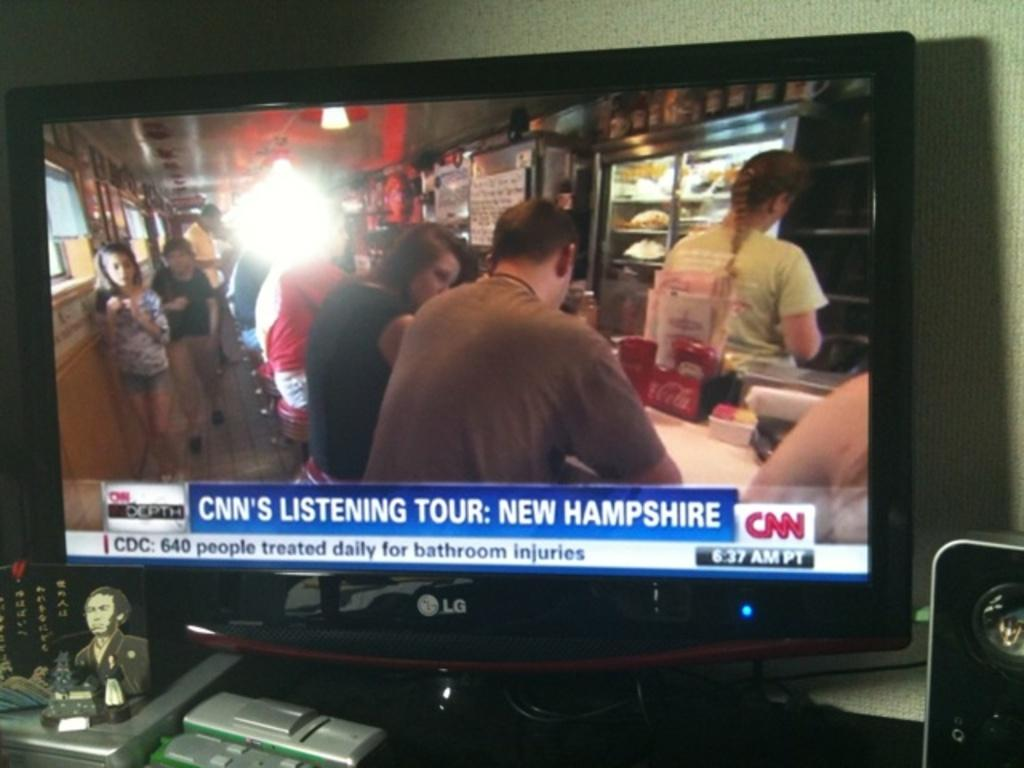<image>
Give a short and clear explanation of the subsequent image. A television displays an image of people seated at a cafe counter that is being used as part of a CNN story on bathroom injuries. 